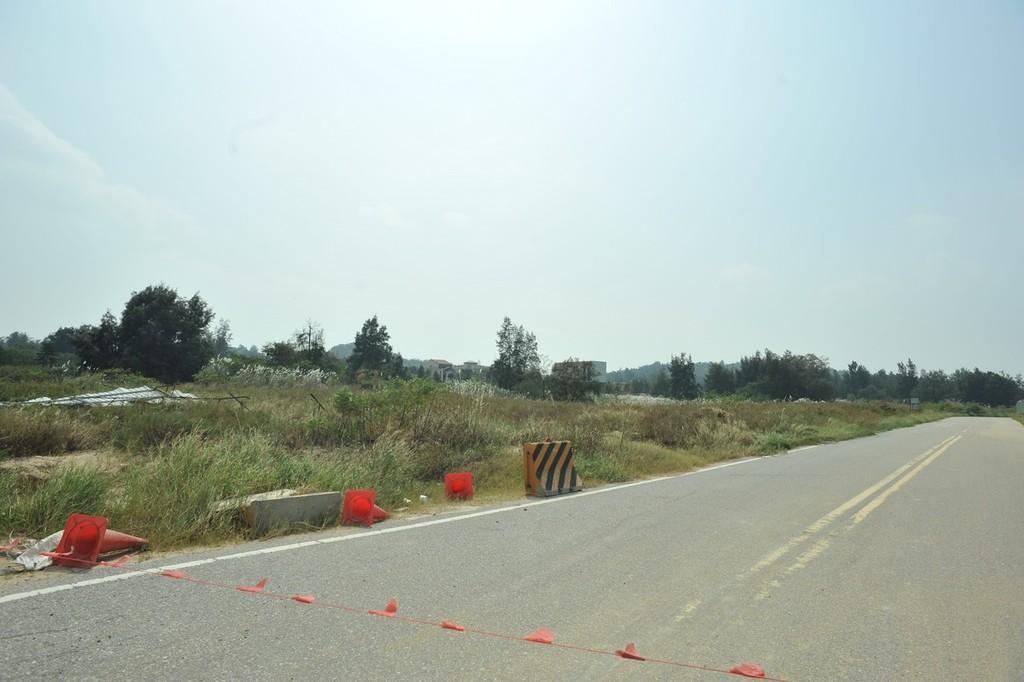In one or two sentences, can you explain what this image depicts? In the center of the image we can see trees, plants, grass, rocks, divider cones, building are present. At the top of the image sky is there. At the bottom of the image road, some flags are there. 